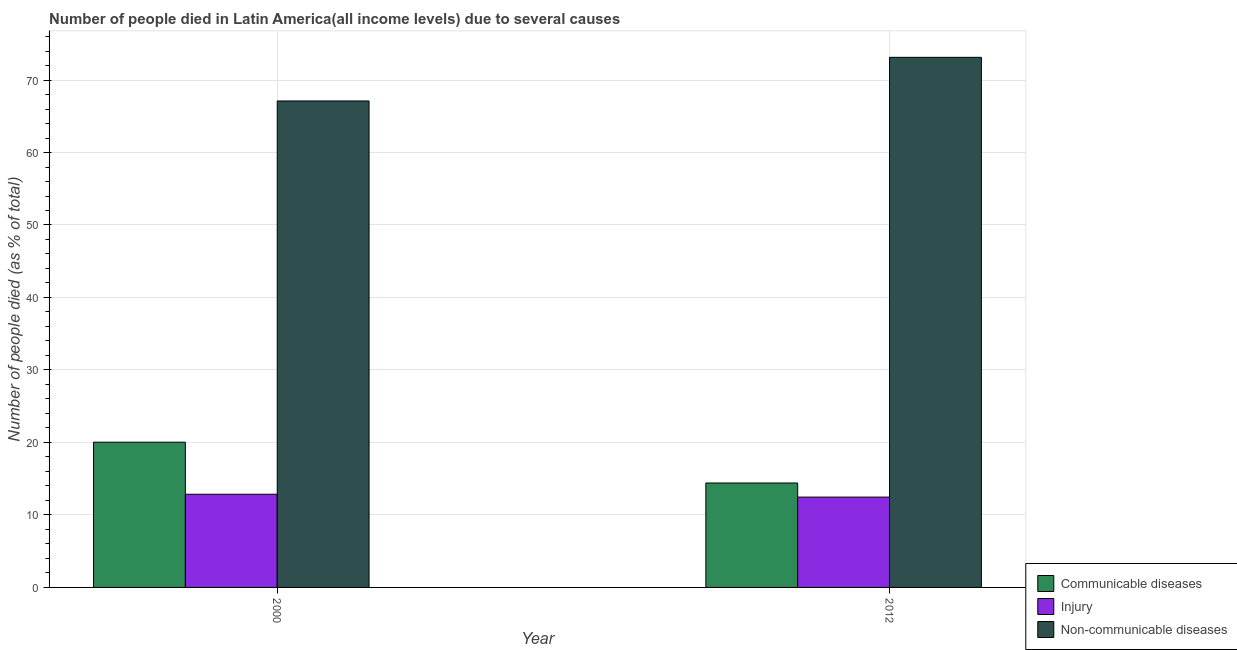Are the number of bars on each tick of the X-axis equal?
Provide a succinct answer. Yes. How many bars are there on the 2nd tick from the left?
Provide a succinct answer. 3. What is the label of the 2nd group of bars from the left?
Offer a terse response. 2012. What is the number of people who died of communicable diseases in 2012?
Your answer should be compact. 14.41. Across all years, what is the maximum number of people who dies of non-communicable diseases?
Keep it short and to the point. 73.13. Across all years, what is the minimum number of people who dies of non-communicable diseases?
Your answer should be very brief. 67.11. In which year was the number of people who died of injury maximum?
Keep it short and to the point. 2000. In which year was the number of people who dies of non-communicable diseases minimum?
Provide a short and direct response. 2000. What is the total number of people who died of injury in the graph?
Provide a short and direct response. 25.31. What is the difference between the number of people who died of injury in 2000 and that in 2012?
Your answer should be compact. 0.39. What is the difference between the number of people who died of communicable diseases in 2000 and the number of people who dies of non-communicable diseases in 2012?
Make the answer very short. 5.63. What is the average number of people who died of communicable diseases per year?
Provide a short and direct response. 17.22. What is the ratio of the number of people who died of injury in 2000 to that in 2012?
Keep it short and to the point. 1.03. What does the 2nd bar from the left in 2012 represents?
Your response must be concise. Injury. What does the 3rd bar from the right in 2000 represents?
Offer a very short reply. Communicable diseases. Are all the bars in the graph horizontal?
Make the answer very short. No. Does the graph contain grids?
Offer a very short reply. Yes. Where does the legend appear in the graph?
Your response must be concise. Bottom right. How many legend labels are there?
Offer a terse response. 3. What is the title of the graph?
Offer a very short reply. Number of people died in Latin America(all income levels) due to several causes. Does "Oil sources" appear as one of the legend labels in the graph?
Make the answer very short. No. What is the label or title of the X-axis?
Your answer should be very brief. Year. What is the label or title of the Y-axis?
Your response must be concise. Number of people died (as % of total). What is the Number of people died (as % of total) in Communicable diseases in 2000?
Provide a short and direct response. 20.04. What is the Number of people died (as % of total) in Injury in 2000?
Ensure brevity in your answer.  12.85. What is the Number of people died (as % of total) of Non-communicable diseases in 2000?
Your answer should be compact. 67.11. What is the Number of people died (as % of total) in Communicable diseases in 2012?
Your response must be concise. 14.41. What is the Number of people died (as % of total) of Injury in 2012?
Ensure brevity in your answer.  12.46. What is the Number of people died (as % of total) in Non-communicable diseases in 2012?
Offer a very short reply. 73.13. Across all years, what is the maximum Number of people died (as % of total) in Communicable diseases?
Provide a short and direct response. 20.04. Across all years, what is the maximum Number of people died (as % of total) of Injury?
Your response must be concise. 12.85. Across all years, what is the maximum Number of people died (as % of total) of Non-communicable diseases?
Make the answer very short. 73.13. Across all years, what is the minimum Number of people died (as % of total) in Communicable diseases?
Make the answer very short. 14.41. Across all years, what is the minimum Number of people died (as % of total) of Injury?
Keep it short and to the point. 12.46. Across all years, what is the minimum Number of people died (as % of total) of Non-communicable diseases?
Offer a very short reply. 67.11. What is the total Number of people died (as % of total) in Communicable diseases in the graph?
Ensure brevity in your answer.  34.45. What is the total Number of people died (as % of total) of Injury in the graph?
Make the answer very short. 25.31. What is the total Number of people died (as % of total) in Non-communicable diseases in the graph?
Keep it short and to the point. 140.24. What is the difference between the Number of people died (as % of total) of Communicable diseases in 2000 and that in 2012?
Your response must be concise. 5.63. What is the difference between the Number of people died (as % of total) in Injury in 2000 and that in 2012?
Provide a short and direct response. 0.39. What is the difference between the Number of people died (as % of total) in Non-communicable diseases in 2000 and that in 2012?
Make the answer very short. -6.02. What is the difference between the Number of people died (as % of total) of Communicable diseases in 2000 and the Number of people died (as % of total) of Injury in 2012?
Provide a short and direct response. 7.58. What is the difference between the Number of people died (as % of total) in Communicable diseases in 2000 and the Number of people died (as % of total) in Non-communicable diseases in 2012?
Give a very brief answer. -53.09. What is the difference between the Number of people died (as % of total) in Injury in 2000 and the Number of people died (as % of total) in Non-communicable diseases in 2012?
Offer a terse response. -60.28. What is the average Number of people died (as % of total) in Communicable diseases per year?
Provide a succinct answer. 17.22. What is the average Number of people died (as % of total) in Injury per year?
Your response must be concise. 12.66. What is the average Number of people died (as % of total) of Non-communicable diseases per year?
Make the answer very short. 70.12. In the year 2000, what is the difference between the Number of people died (as % of total) of Communicable diseases and Number of people died (as % of total) of Injury?
Offer a terse response. 7.18. In the year 2000, what is the difference between the Number of people died (as % of total) in Communicable diseases and Number of people died (as % of total) in Non-communicable diseases?
Your answer should be very brief. -47.07. In the year 2000, what is the difference between the Number of people died (as % of total) in Injury and Number of people died (as % of total) in Non-communicable diseases?
Keep it short and to the point. -54.26. In the year 2012, what is the difference between the Number of people died (as % of total) in Communicable diseases and Number of people died (as % of total) in Injury?
Make the answer very short. 1.95. In the year 2012, what is the difference between the Number of people died (as % of total) of Communicable diseases and Number of people died (as % of total) of Non-communicable diseases?
Offer a very short reply. -58.72. In the year 2012, what is the difference between the Number of people died (as % of total) in Injury and Number of people died (as % of total) in Non-communicable diseases?
Offer a very short reply. -60.67. What is the ratio of the Number of people died (as % of total) of Communicable diseases in 2000 to that in 2012?
Provide a short and direct response. 1.39. What is the ratio of the Number of people died (as % of total) in Injury in 2000 to that in 2012?
Your response must be concise. 1.03. What is the ratio of the Number of people died (as % of total) in Non-communicable diseases in 2000 to that in 2012?
Ensure brevity in your answer.  0.92. What is the difference between the highest and the second highest Number of people died (as % of total) of Communicable diseases?
Provide a short and direct response. 5.63. What is the difference between the highest and the second highest Number of people died (as % of total) of Injury?
Give a very brief answer. 0.39. What is the difference between the highest and the second highest Number of people died (as % of total) in Non-communicable diseases?
Provide a short and direct response. 6.02. What is the difference between the highest and the lowest Number of people died (as % of total) in Communicable diseases?
Keep it short and to the point. 5.63. What is the difference between the highest and the lowest Number of people died (as % of total) in Injury?
Ensure brevity in your answer.  0.39. What is the difference between the highest and the lowest Number of people died (as % of total) of Non-communicable diseases?
Your answer should be very brief. 6.02. 